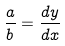<formula> <loc_0><loc_0><loc_500><loc_500>\frac { a } { b } = \frac { d y } { d x }</formula> 